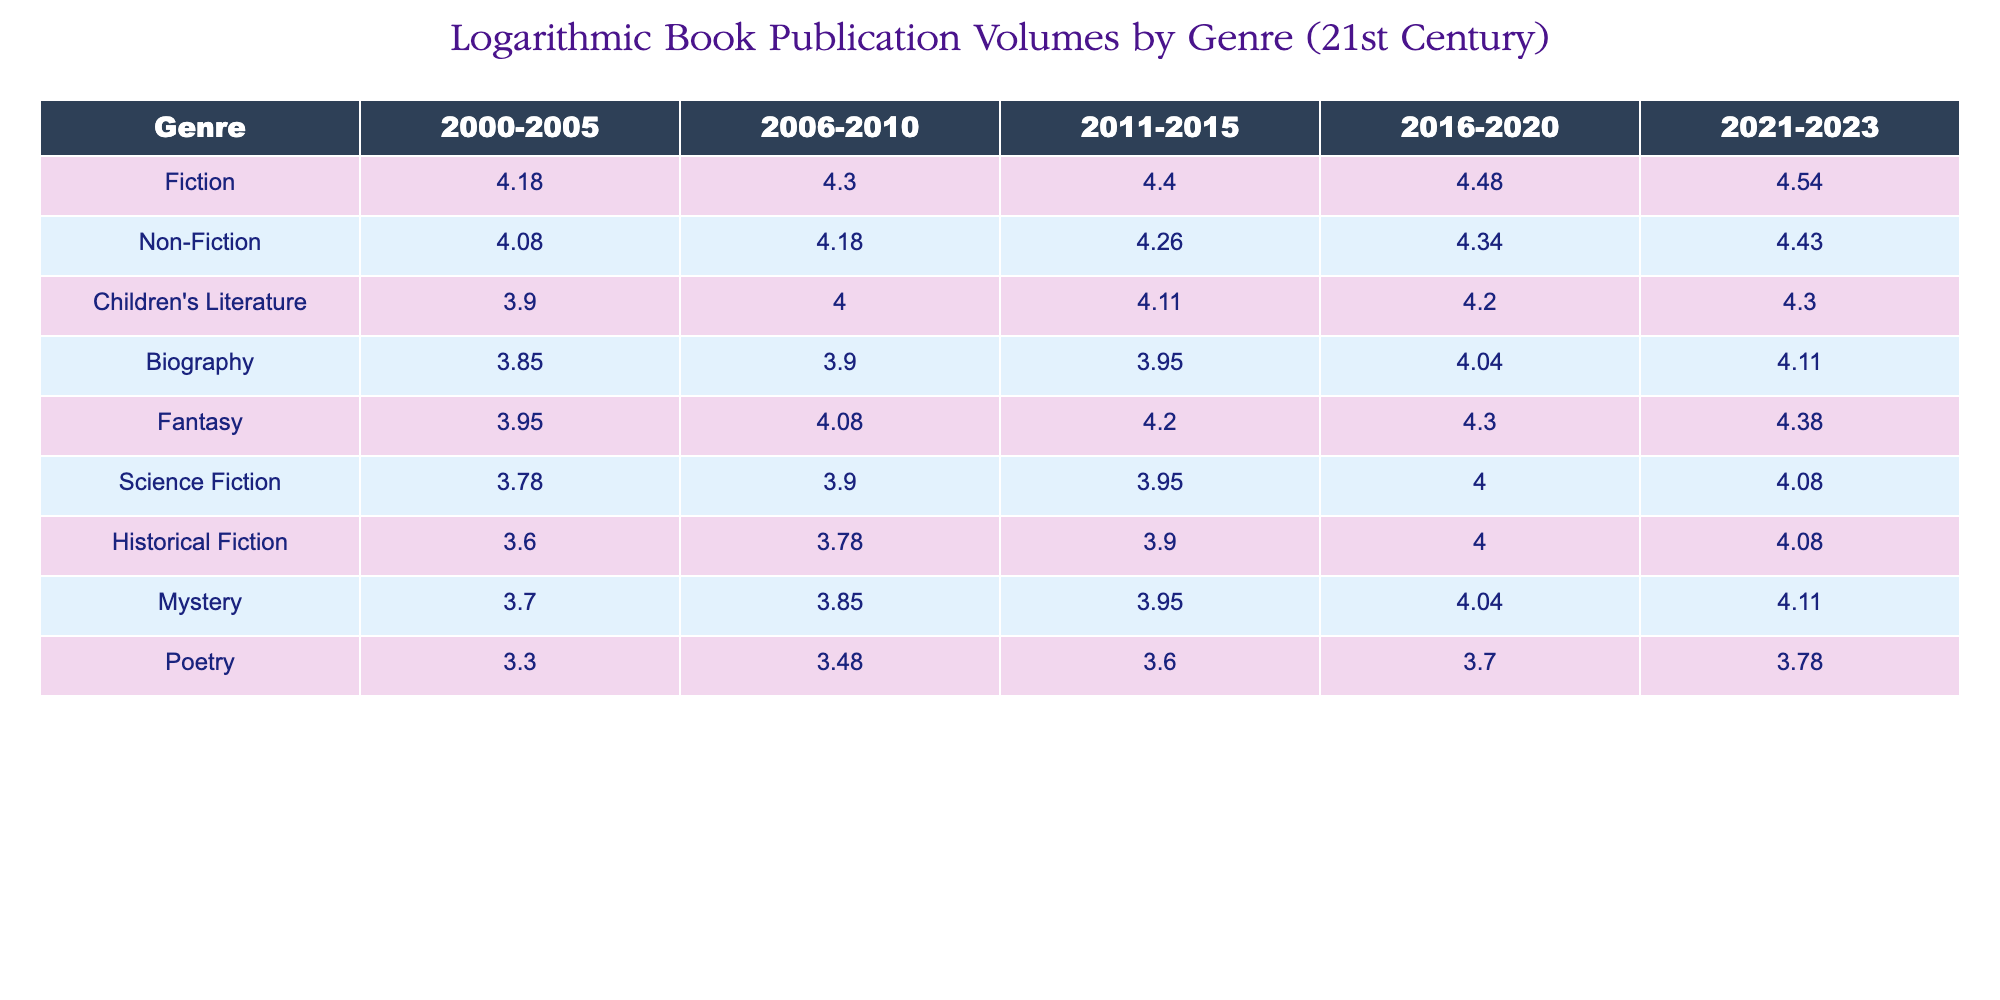What was the publication volume for Fiction in the years 2016-2020? The table indicates that the publication volume for Fiction during the years 2016-2020 was 30000.
Answer: 30000 What is the total publication volume for Children's Literature from 2000 to 2023? To find the total, we add the values for Children's Literature: 8000 + 10000 + 13000 + 16000 + 20000 = 67000.
Answer: 67000 Is there a higher publication volume for Non-Fiction than for Biography in the years 2021-2023? In 2021-2023, Non-Fiction had a volume of 27000, while Biography had a volume of 13000. Since 27000 > 13000, the answer is yes.
Answer: Yes Which genre saw the highest increase in publication volume from 2000-2005 to 2021-2023? Examining the growth: Fiction increased from 15000 to 35000 (20000 increase), Non-Fiction from 12000 to 27000 (15000 increase), Children's Literature from 8000 to 20000 (12000 increase), and so on. The genre with the highest increase is Fiction with a 20000 increase.
Answer: Fiction What is the average publication volume for Mystery across all the specified time periods? To calculate the average, we sum the volumes for Mystery: 5000 + 7000 + 9000 + 11000 + 13000 = 50000, which we then divide by the number of periods (5). The average is 50000 / 5 = 10000.
Answer: 10000 Was the publication volume for Fantasy consistently higher than that of Science Fiction across all periods? Analyzing the data: Fantasy had 9000, 12000, 16000, 20000, 24000, while Science Fiction had 6000, 8000, 9000, 10000, 12000. In every period, Fantasy was greater than Science Fiction, confirming the claim.
Answer: Yes What is the difference in publication volume between Historical Fiction and Poetry in 2011-2015? For Historical Fiction, the volume is 8000, and for Poetry, it is 4000 in 2011-2015. The difference is 8000 - 4000 = 4000.
Answer: 4000 Which genre had the second highest publication volume in the 2021-2023 period? In 2021-2023, the publication volumes by genre were: Fiction (35000), Non-Fiction (27000), Children's Literature (20000), Biography (13000), etc. After Fiction, the second highest is Non-Fiction at 27000.
Answer: Non-Fiction What is the percentage increase in publication volume for Biography from 2000-2005 to 2016-2020? The value for Biography increased from 7000 to 11000. The increase is 11000 - 7000 = 4000. The percentage increase is (4000 / 7000) * 100 = 57.14%.
Answer: 57.14% 